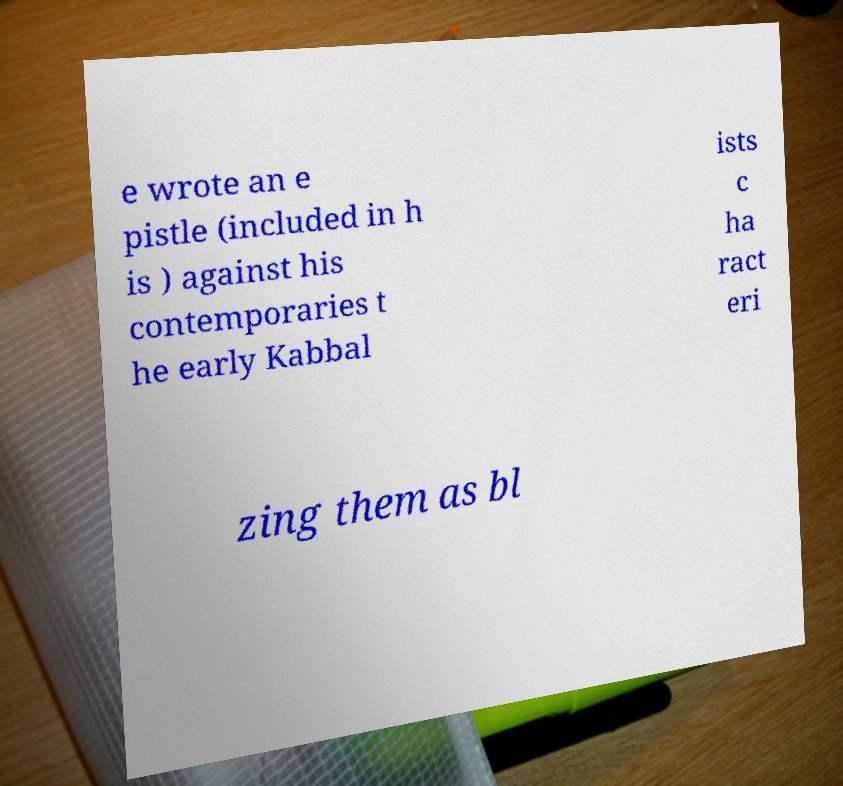Could you extract and type out the text from this image? e wrote an e pistle (included in h is ) against his contemporaries t he early Kabbal ists c ha ract eri zing them as bl 